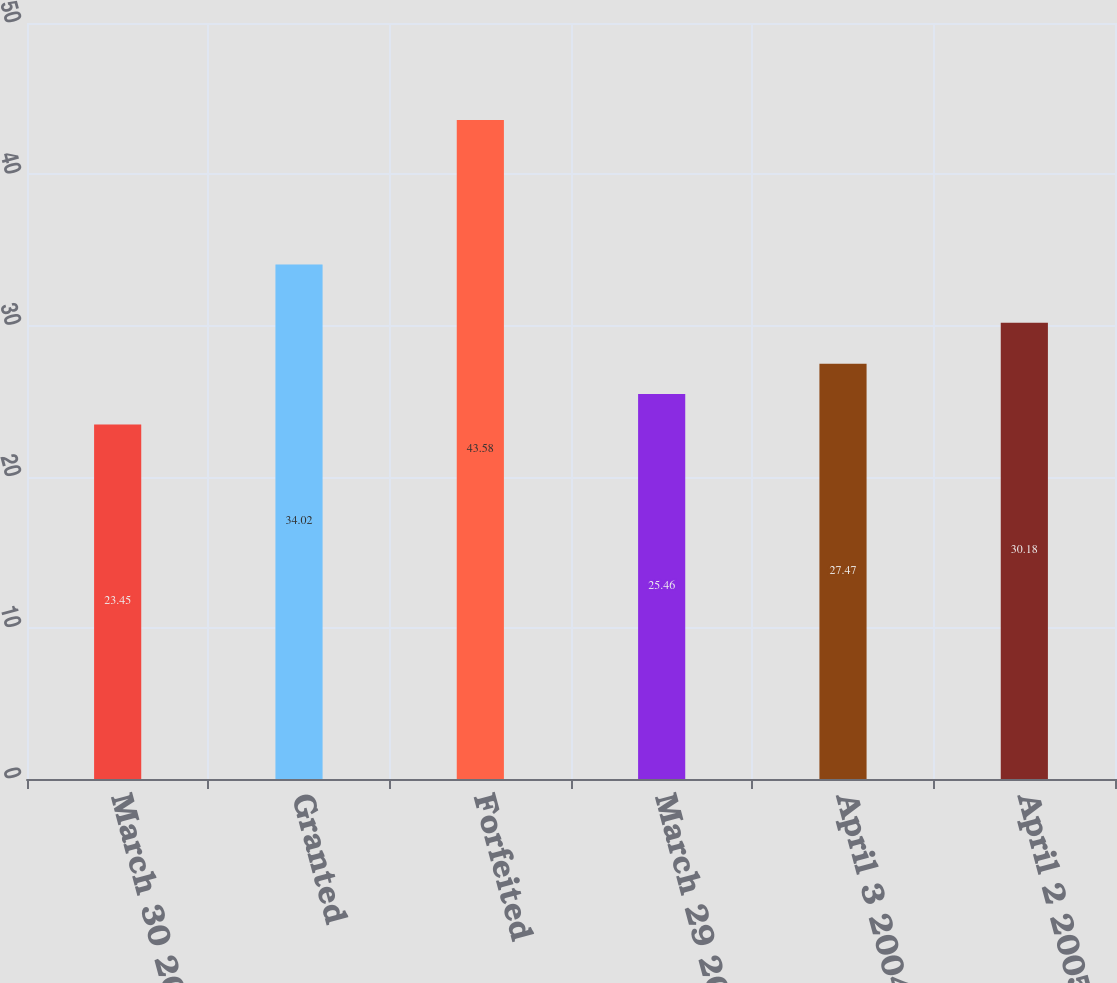Convert chart. <chart><loc_0><loc_0><loc_500><loc_500><bar_chart><fcel>March 30 2002<fcel>Granted<fcel>Forfeited<fcel>March 29 2003<fcel>April 3 2004<fcel>April 2 2005<nl><fcel>23.45<fcel>34.02<fcel>43.58<fcel>25.46<fcel>27.47<fcel>30.18<nl></chart> 